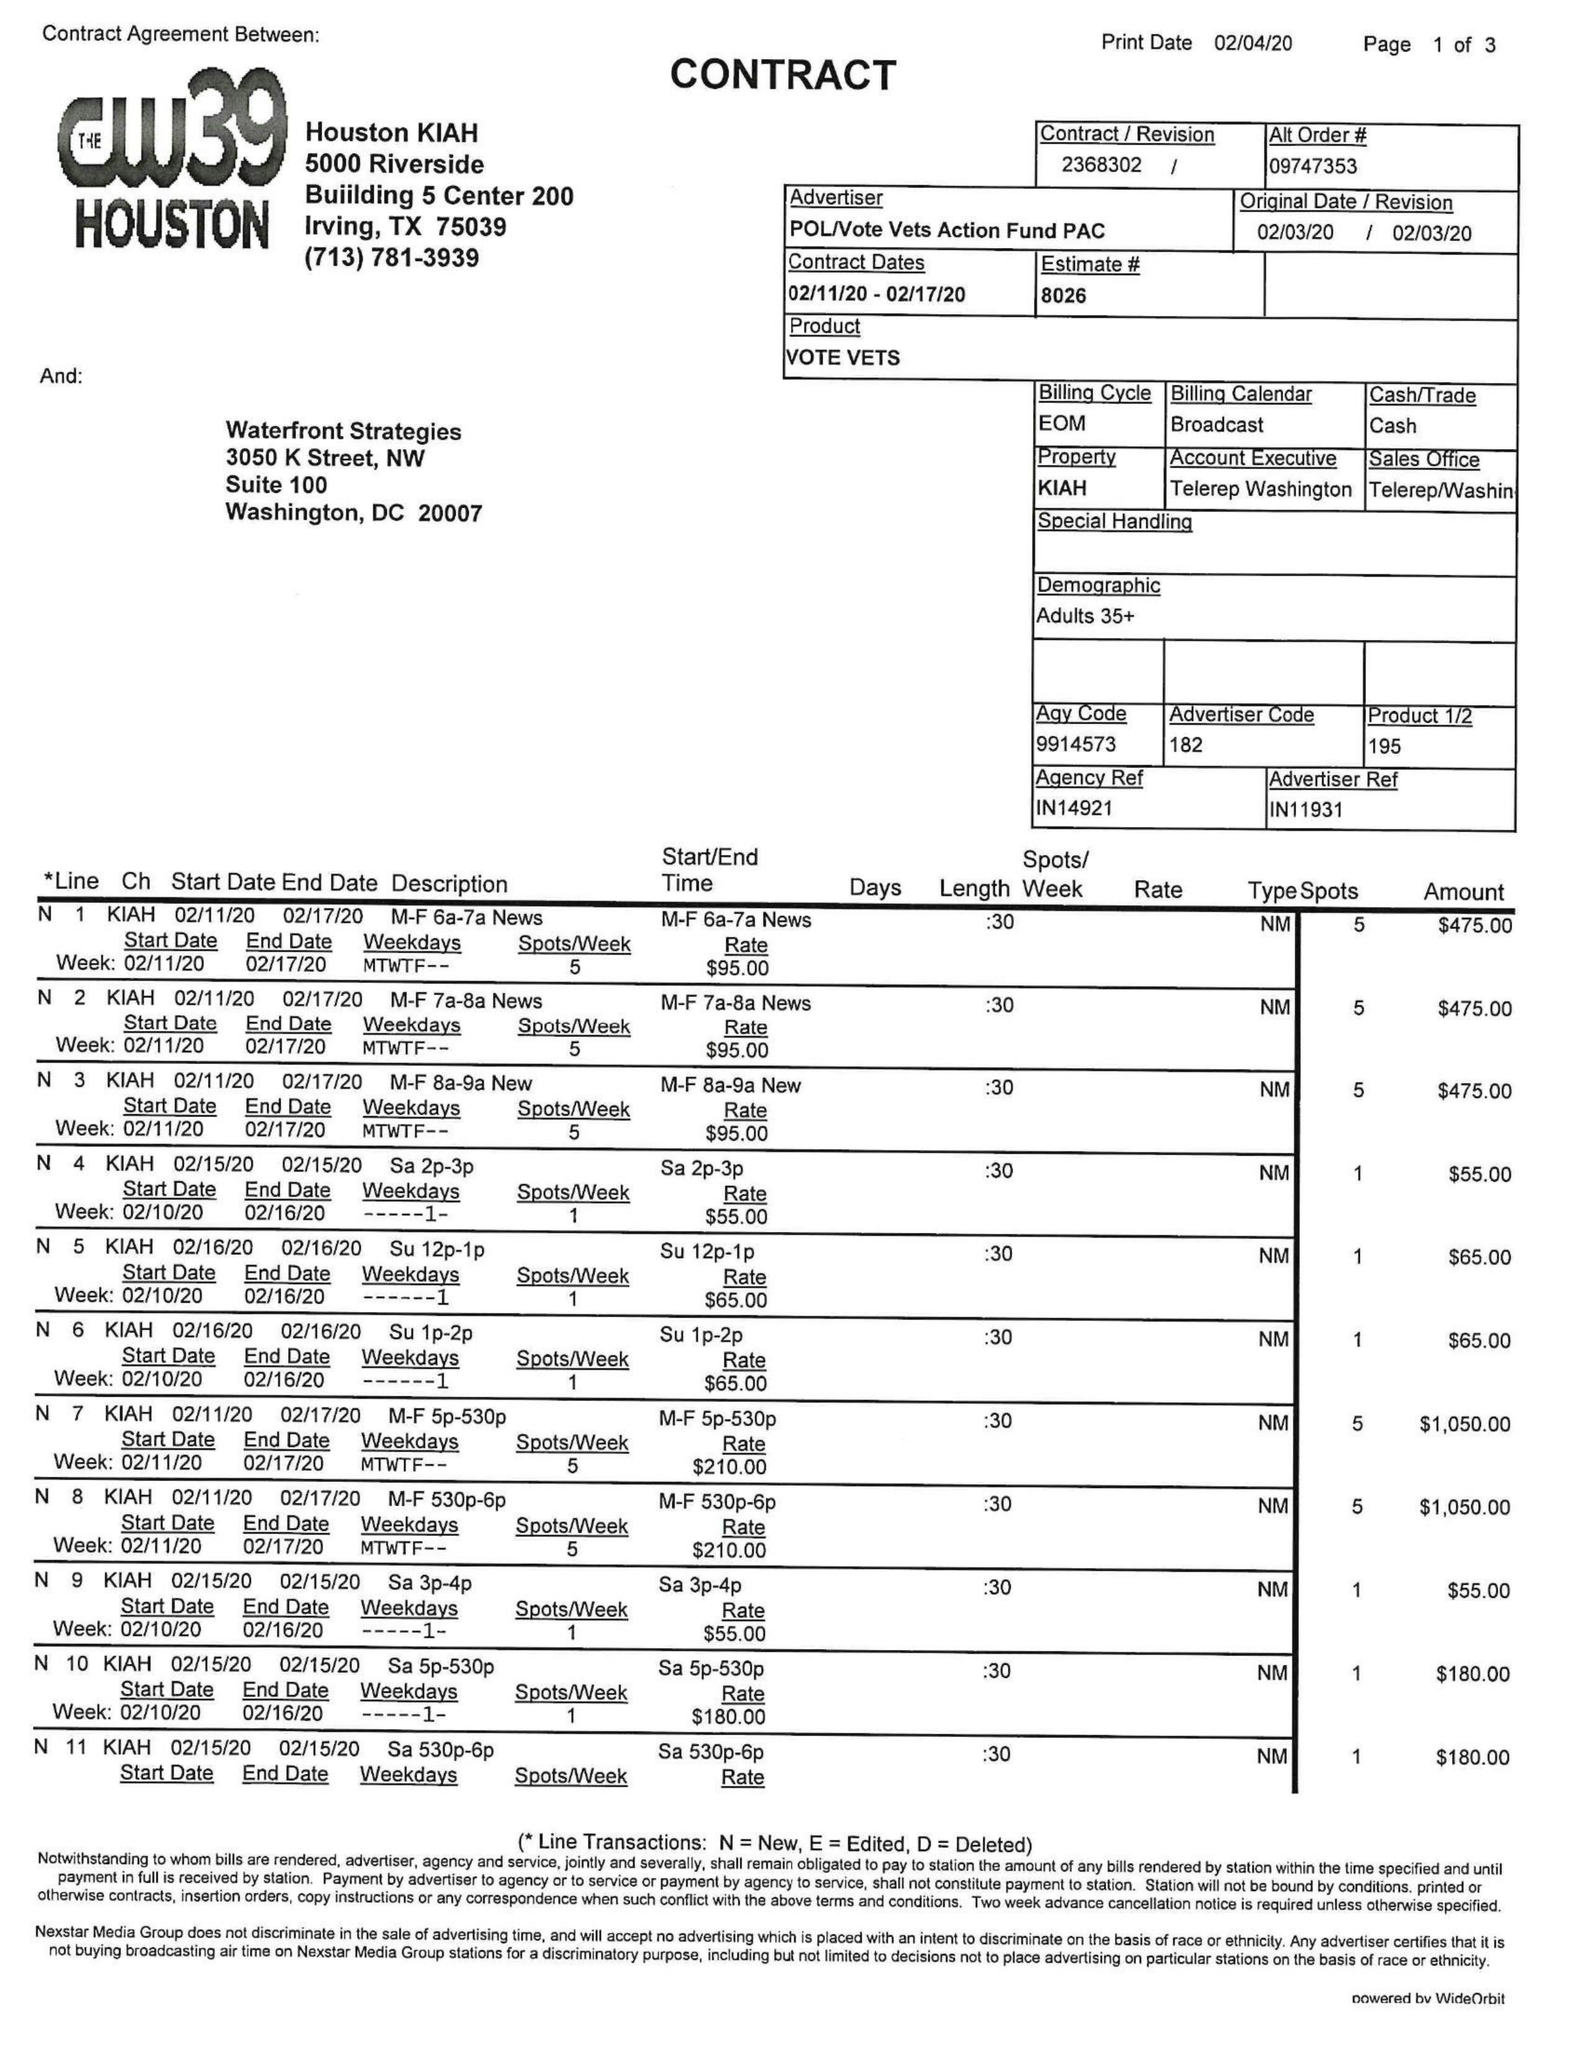What is the value for the gross_amount?
Answer the question using a single word or phrase. 17630.00 